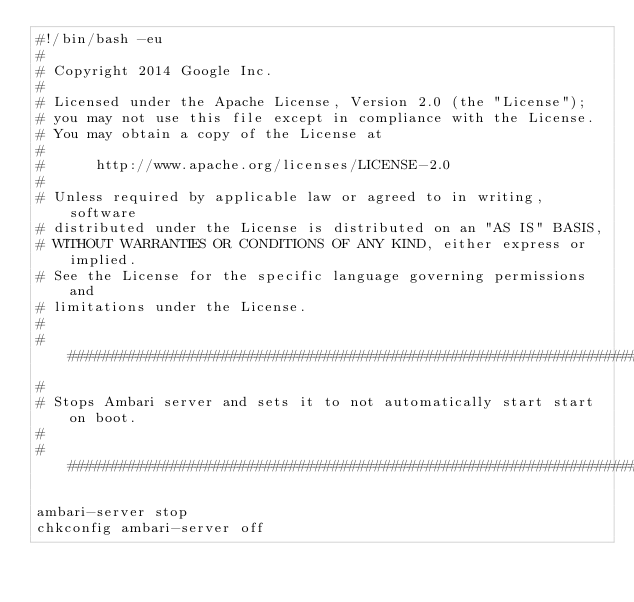<code> <loc_0><loc_0><loc_500><loc_500><_Bash_>#!/bin/bash -eu
#
# Copyright 2014 Google Inc.
#
# Licensed under the Apache License, Version 2.0 (the "License");
# you may not use this file except in compliance with the License.
# You may obtain a copy of the License at
#
#      http://www.apache.org/licenses/LICENSE-2.0
#
# Unless required by applicable law or agreed to in writing, software
# distributed under the License is distributed on an "AS IS" BASIS,
# WITHOUT WARRANTIES OR CONDITIONS OF ANY KIND, either express or implied.
# See the License for the specific language governing permissions and
# limitations under the License.
#
################################################################################
#
# Stops Ambari server and sets it to not automatically start start on boot.
#
################################################################################

ambari-server stop
chkconfig ambari-server off
</code> 